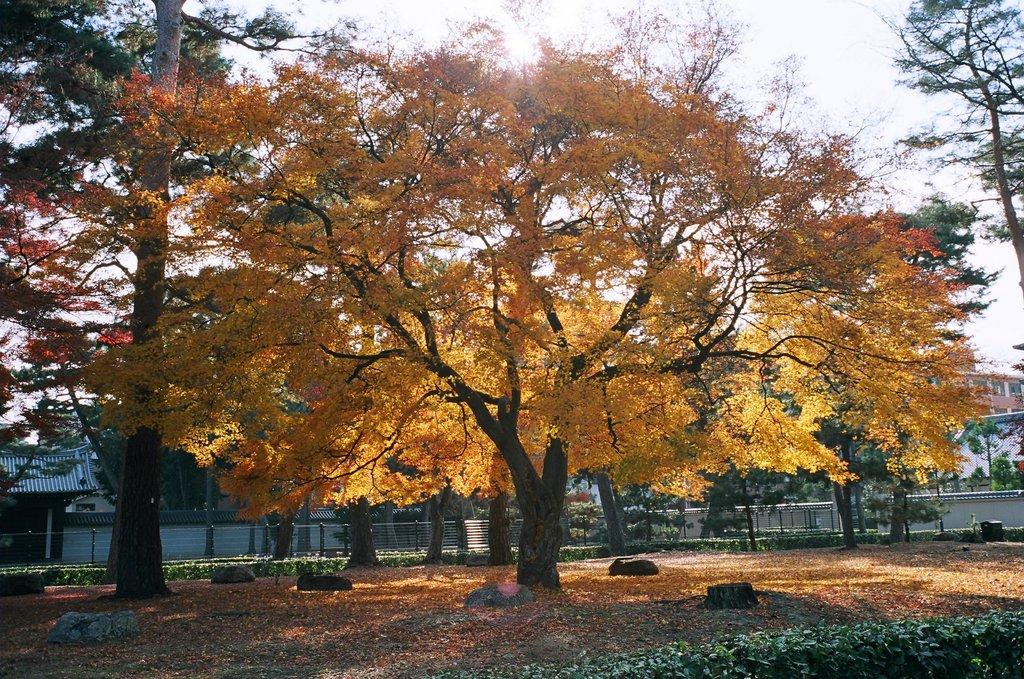What type of natural vegetation is present in the image? There are many trees in the image. What type of structures can be seen in the background of the image? There are houses and buildings visible in the background of the image. What type of flight can be seen taking off from the trees in the image? There is no flight present in the image; it only features trees, houses, and buildings. What type of iron object is visible in the image? There is no iron object present in the image. 